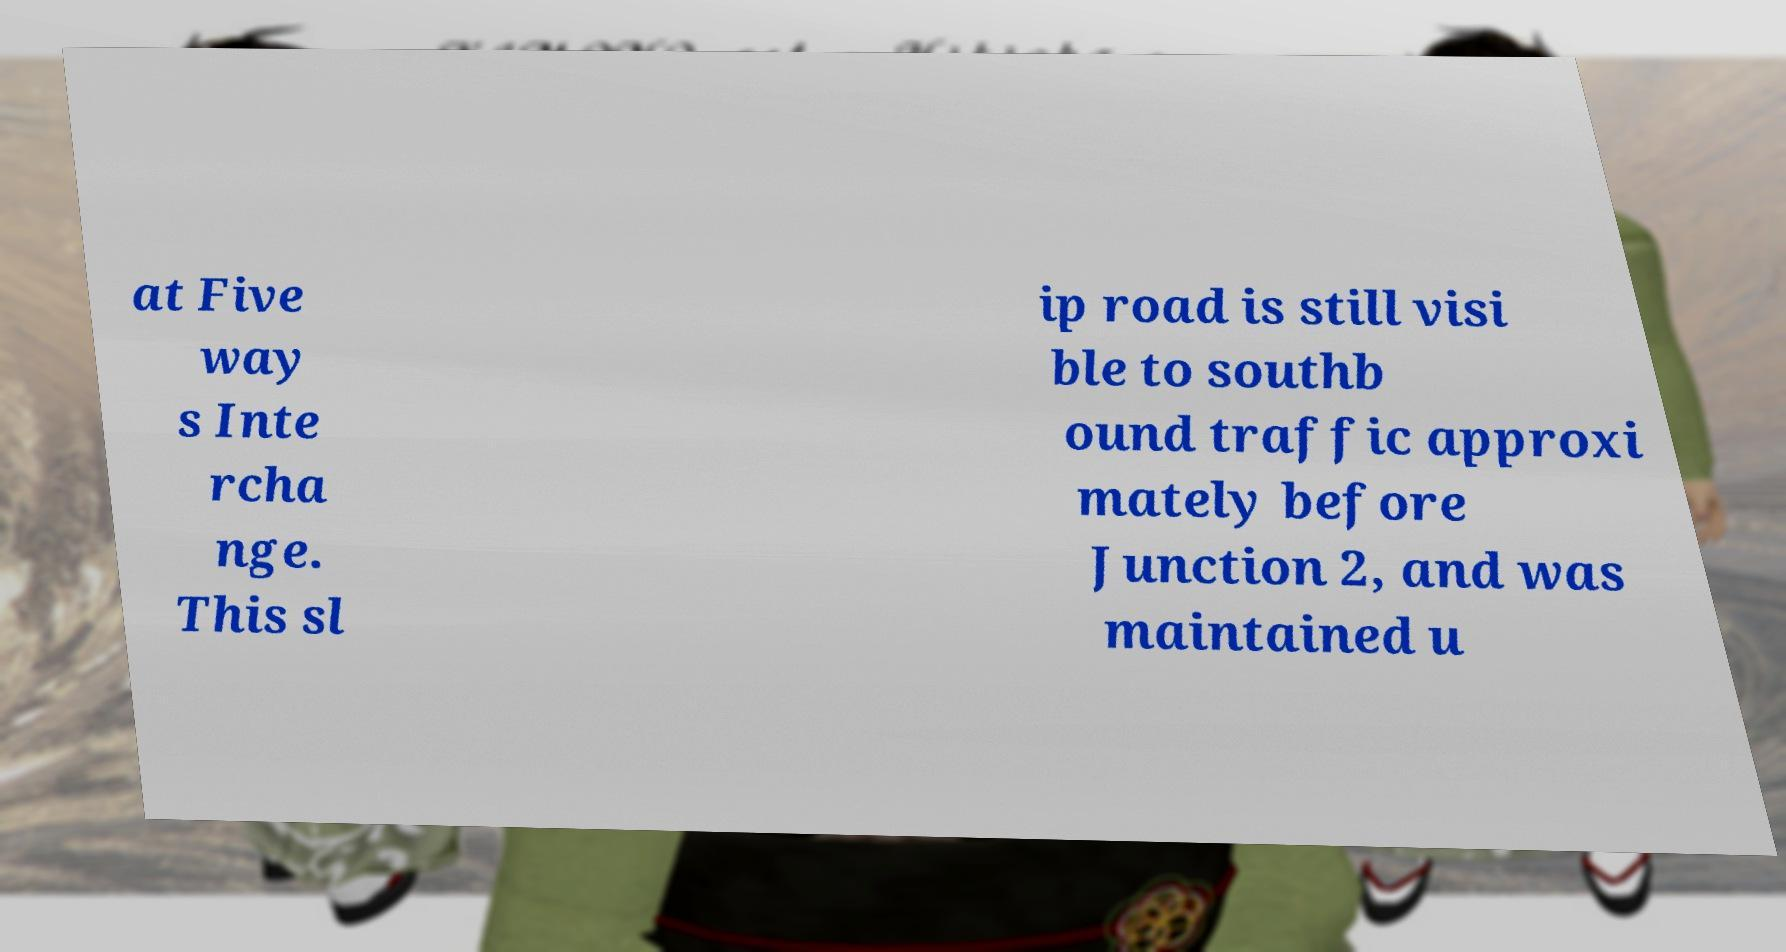Could you extract and type out the text from this image? at Five way s Inte rcha nge. This sl ip road is still visi ble to southb ound traffic approxi mately before Junction 2, and was maintained u 